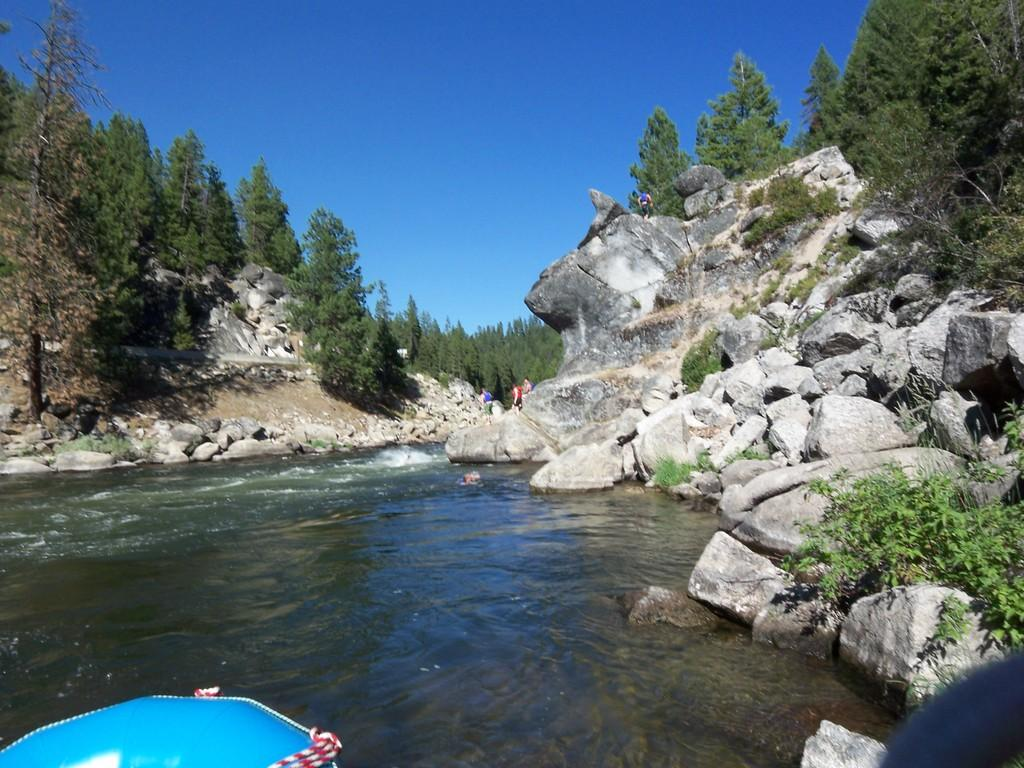What is located in the middle of the image? There are stones, trees, people, water, and waves in the middle of the image. What can be seen at the bottom of the image? There is an object, stones, and plants at the bottom of the image. What is visible at the top of the image? The sky is visible at the top of the image. What sound can be heard coming from the table in the image? There is no table present in the image, so it is not possible to determine what sound might be heard. 